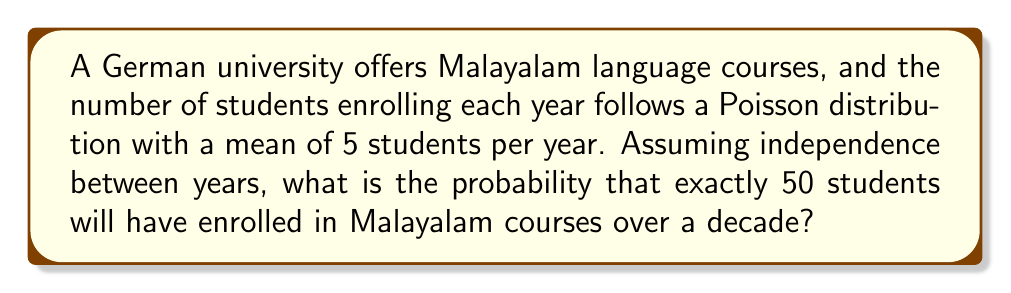Could you help me with this problem? Let's approach this step-by-step:

1) The number of students enrolling each year follows a Poisson distribution with λ = 5.

2) We want to find the total number of students over 10 years. Since we assume independence between years, this is the sum of 10 independent Poisson distributions.

3) A key property of Poisson distributions is that the sum of independent Poisson distributions is also Poisson distributed. The parameter of the resulting distribution is the sum of the individual parameters.

4) So, for 10 years, we have:
   $\lambda_{total} = 10 * 5 = 50$

5) Now, we're looking for the probability of exactly 50 students over 10 years. This follows a Poisson distribution with λ = 50.

6) The probability mass function for a Poisson distribution is:

   $$P(X = k) = \frac{e^{-\lambda}\lambda^k}{k!}$$

7) Substituting our values:

   $$P(X = 50) = \frac{e^{-50}50^{50}}{50!}$$

8) Calculating this (you would use a calculator or computer for this):

   $$P(X = 50) \approx 0.0568$$

Thus, the probability of exactly 50 students enrolling over a decade is approximately 0.0568 or 5.68%.
Answer: $\frac{e^{-50}50^{50}}{50!} \approx 0.0568$ 